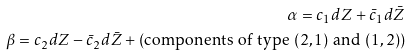<formula> <loc_0><loc_0><loc_500><loc_500>\alpha = c _ { 1 } d Z + \bar { c } _ { 1 } d \bar { Z } \\ \beta = c _ { 2 } d Z - \bar { c } _ { 2 } d \bar { Z } + \left ( \text {components of type } ( 2 , 1 ) \text { and } ( 1 , 2 ) \right )</formula> 